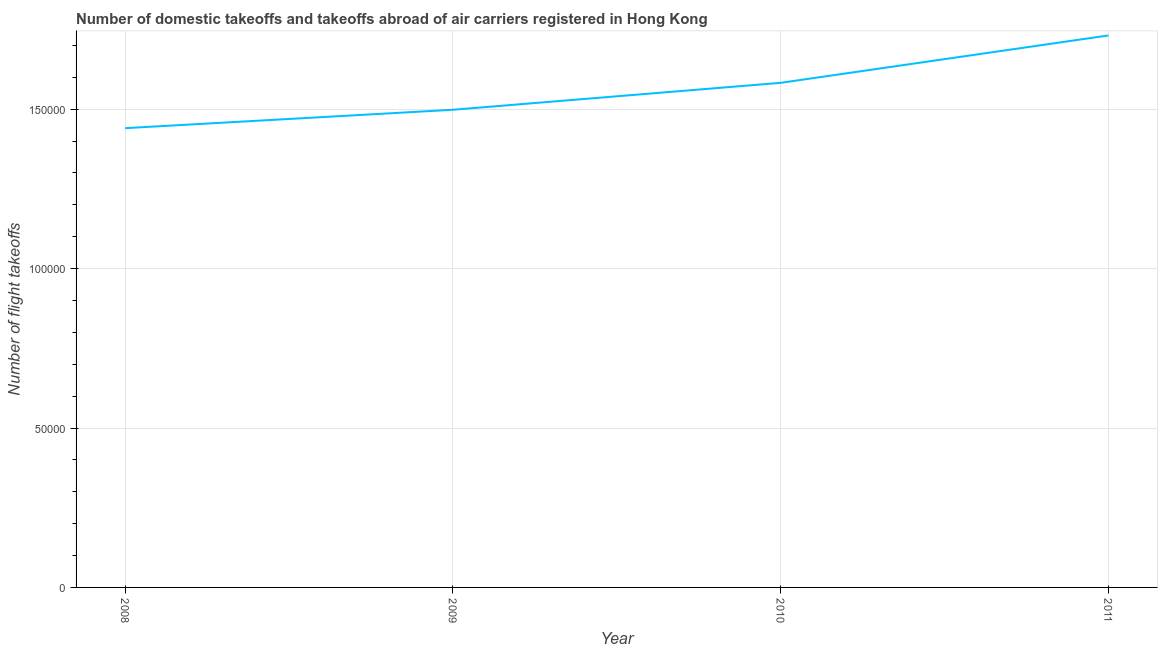What is the number of flight takeoffs in 2010?
Your answer should be very brief. 1.58e+05. Across all years, what is the maximum number of flight takeoffs?
Your response must be concise. 1.73e+05. Across all years, what is the minimum number of flight takeoffs?
Your answer should be compact. 1.44e+05. In which year was the number of flight takeoffs minimum?
Make the answer very short. 2008. What is the sum of the number of flight takeoffs?
Provide a succinct answer. 6.25e+05. What is the difference between the number of flight takeoffs in 2008 and 2011?
Your answer should be very brief. -2.91e+04. What is the average number of flight takeoffs per year?
Ensure brevity in your answer.  1.56e+05. What is the median number of flight takeoffs?
Keep it short and to the point. 1.54e+05. In how many years, is the number of flight takeoffs greater than 130000 ?
Provide a short and direct response. 4. Do a majority of the years between 2009 and 2011 (inclusive) have number of flight takeoffs greater than 100000 ?
Make the answer very short. Yes. What is the ratio of the number of flight takeoffs in 2008 to that in 2011?
Keep it short and to the point. 0.83. What is the difference between the highest and the second highest number of flight takeoffs?
Give a very brief answer. 1.49e+04. Is the sum of the number of flight takeoffs in 2009 and 2010 greater than the maximum number of flight takeoffs across all years?
Provide a short and direct response. Yes. What is the difference between the highest and the lowest number of flight takeoffs?
Provide a short and direct response. 2.91e+04. How many lines are there?
Your answer should be compact. 1. How many years are there in the graph?
Ensure brevity in your answer.  4. What is the difference between two consecutive major ticks on the Y-axis?
Offer a terse response. 5.00e+04. What is the title of the graph?
Make the answer very short. Number of domestic takeoffs and takeoffs abroad of air carriers registered in Hong Kong. What is the label or title of the X-axis?
Your response must be concise. Year. What is the label or title of the Y-axis?
Your response must be concise. Number of flight takeoffs. What is the Number of flight takeoffs in 2008?
Provide a short and direct response. 1.44e+05. What is the Number of flight takeoffs in 2009?
Keep it short and to the point. 1.50e+05. What is the Number of flight takeoffs in 2010?
Give a very brief answer. 1.58e+05. What is the Number of flight takeoffs of 2011?
Give a very brief answer. 1.73e+05. What is the difference between the Number of flight takeoffs in 2008 and 2009?
Give a very brief answer. -5770. What is the difference between the Number of flight takeoffs in 2008 and 2010?
Your response must be concise. -1.42e+04. What is the difference between the Number of flight takeoffs in 2008 and 2011?
Provide a short and direct response. -2.91e+04. What is the difference between the Number of flight takeoffs in 2009 and 2010?
Provide a short and direct response. -8446. What is the difference between the Number of flight takeoffs in 2009 and 2011?
Your answer should be compact. -2.33e+04. What is the difference between the Number of flight takeoffs in 2010 and 2011?
Provide a succinct answer. -1.49e+04. What is the ratio of the Number of flight takeoffs in 2008 to that in 2010?
Provide a short and direct response. 0.91. What is the ratio of the Number of flight takeoffs in 2008 to that in 2011?
Provide a succinct answer. 0.83. What is the ratio of the Number of flight takeoffs in 2009 to that in 2010?
Make the answer very short. 0.95. What is the ratio of the Number of flight takeoffs in 2009 to that in 2011?
Provide a succinct answer. 0.86. What is the ratio of the Number of flight takeoffs in 2010 to that in 2011?
Make the answer very short. 0.91. 